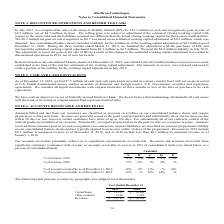From Ricebran Technologies's financial document, What are the respective accounts receivables as a percentage of revenue from customers A and B in 2019? The document shows two values: 11% and 9%. From the document: "% of revenue, 2019 11% 9% 16% 3% 2% % of revenue, 2019 11% 9% 16% 3% 2%..." Also, What are the respective accounts receivables as a percentage of revenue from customers B and C in 2019? The document shows two values: 9% and 16%. From the document: "% of revenue, 2019 11% 9% 16% 3% 2% % of revenue, 2019 11% 9% 16% 3% 2%..." Also, What are the respective accounts receivables as a percentage of revenue from customers C and D in 2019? The document shows two values: 16% and 3%. From the document: "% of revenue, 2019 11% 9% 16% 3% 2% % of revenue, 2019 11% 9% 16% 3% 2%..." Also, can you calculate: What is the change in the amount of accounts receivable as a percentage of revenue from customer A between 2018 and 2019? Based on the calculation: 11 - 17 , the result is -6. This is based on the information: "% of revenue, 2019 11% 9% 16% 3% 2% % of revenue, 2018 17% 14% 1% 4% -%..." The key data points involved are: 11, 17. Also, can you calculate: What is the change in the amount of accounts receivable as a percentage of revenue from customer B between 2018 and 2019? Based on the calculation: 9 - 14 , the result is -5. This is based on the information: "% of revenue, 2018 17% 14% 1% 4% -% % of revenue, 2019 11% 9% 16% 3% 2%..." The key data points involved are: 14, 9. Also, can you calculate: What is the change in the amount of accounts receivable as a percentage of revenue from customer C between 2018 and 2019? Based on the calculation: 16 - 1 , the result is 15. This is based on the information: "% of revenue, 2019 11% 9% 16% 3% 2% % of revenue, 2019 11% 9% 16% 3% 2%..." The key data points involved are: 16. 